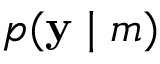<formula> <loc_0><loc_0><loc_500><loc_500>p ( y | m )</formula> 